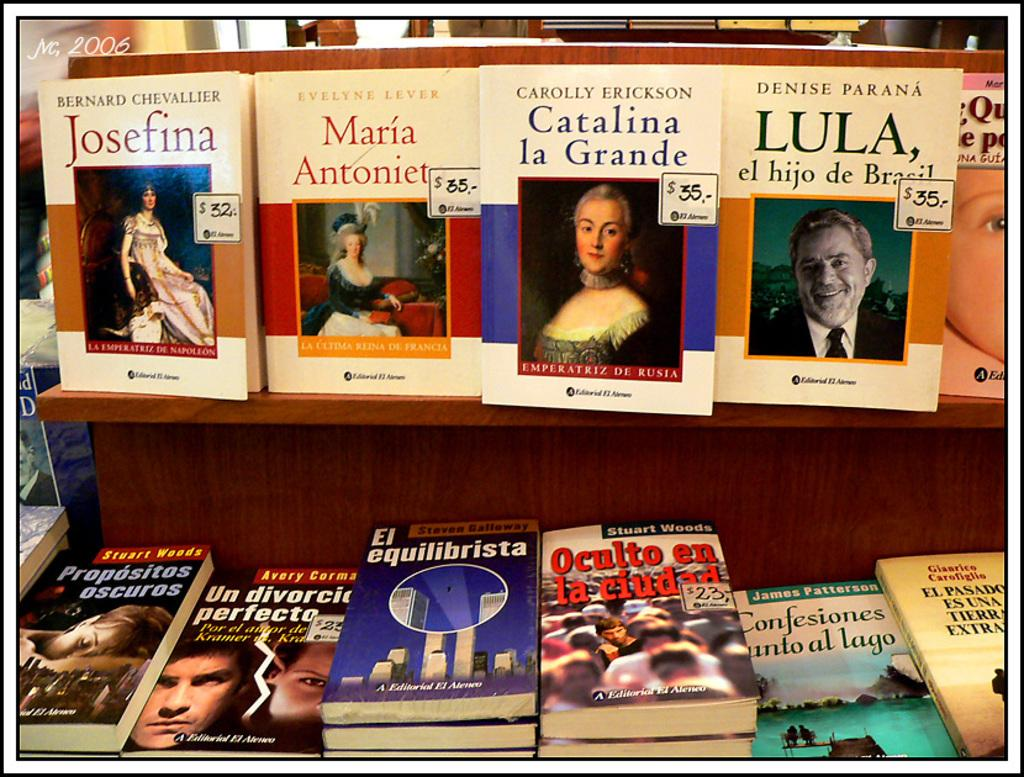What is the main subject of the image? The main subject of the image is a group of books. Where are some of the books located in the image? Some of the books are on a rack in the image. What types of images are depicted on the books? People, buildings, and water are depicted on the books. What type of leather is used to make the books in the image? The provided facts do not mention the material used to make the books, so we cannot determine if leather is used or not. --- Facts: 1. There is a person holding a camera in the image. 2. The person is standing on a bridge. 3. The bridge is over a river. 4. There are trees on both sides of the river. 5. The sky is visible in the image. Absurd Topics: parrot, sandcastle, bicycle Conversation: What is the person in the image holding? The person in the image is holding a camera. Where is the person standing in the image? The person is standing on a bridge in the image. What is the bridge positioned over in the image? The bridge is over a river in the image. What can be seen on both sides of the river in the image? There are trees on both sides of the river in the image. What is visible in the sky in the image? The sky is visible in the image. Reasoning: Let's think step by step in order to produce the conversation. We start by identifying the main subject of the image, which is the person holding a camera. Then, we describe the location of the person, who is standing on a bridge over a river. Next, we mention the surrounding environment, which includes trees on both sides of the river. Finally, we acknowledge the presence of the sky in the image. Absurd Question/Answer: Can you see a parrot perched on the person's shoulder in the image? No, there is no parrot present in the image. Is there a sandcastle visible on the riverbank in the image? No, there is no sandcastle present in the image. 